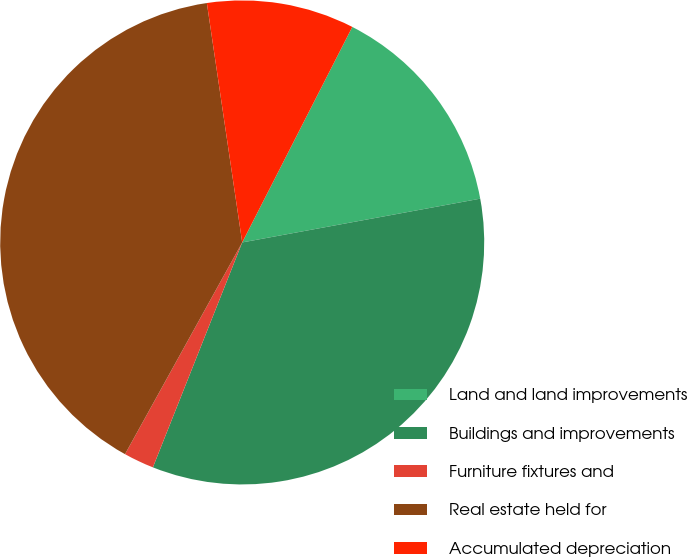<chart> <loc_0><loc_0><loc_500><loc_500><pie_chart><fcel>Land and land improvements<fcel>Buildings and improvements<fcel>Furniture fixtures and<fcel>Real estate held for<fcel>Accumulated depreciation<nl><fcel>14.59%<fcel>33.91%<fcel>2.03%<fcel>39.62%<fcel>9.85%<nl></chart> 